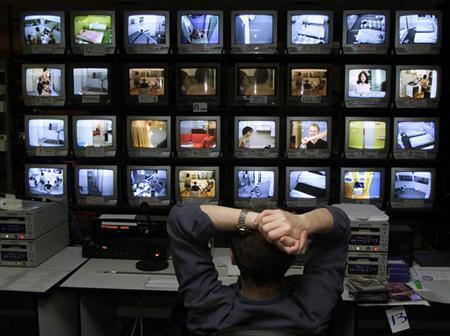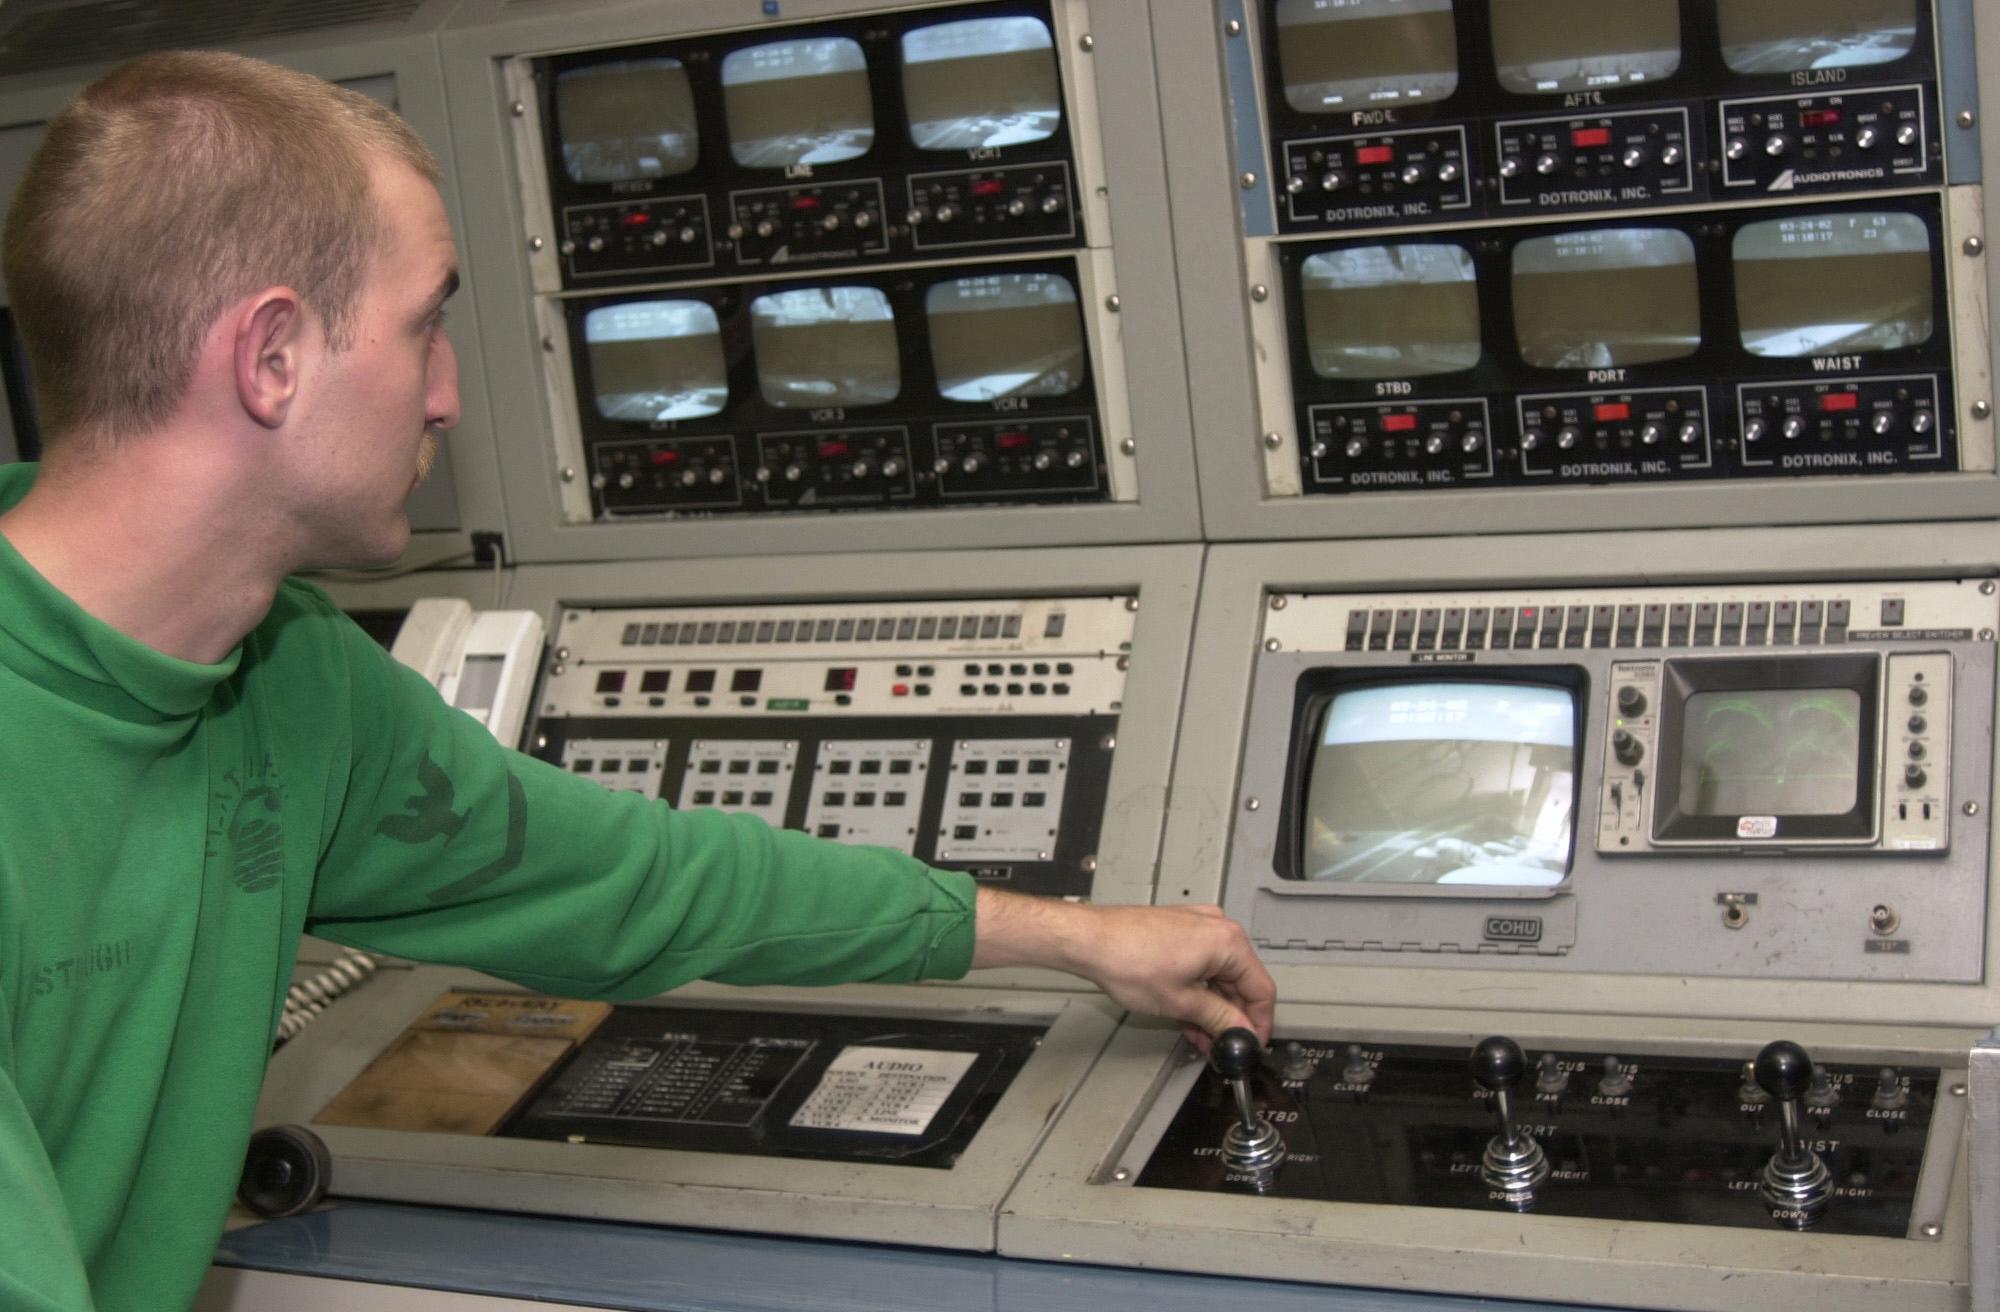The first image is the image on the left, the second image is the image on the right. Assess this claim about the two images: "An image shows the back of a man seated before many screens.". Correct or not? Answer yes or no. Yes. The first image is the image on the left, the second image is the image on the right. Given the left and right images, does the statement "An image shows a man reaching to touch a control panel." hold true? Answer yes or no. Yes. 